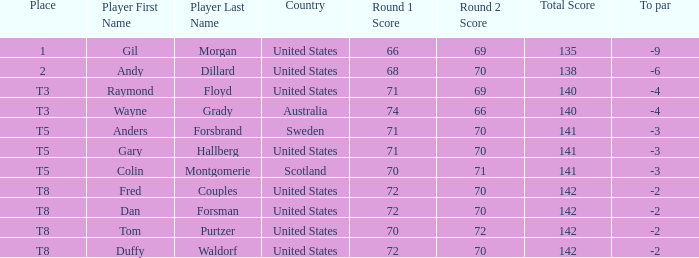What is the To par of the Player with a Score of 70-71=141? -3.0. 